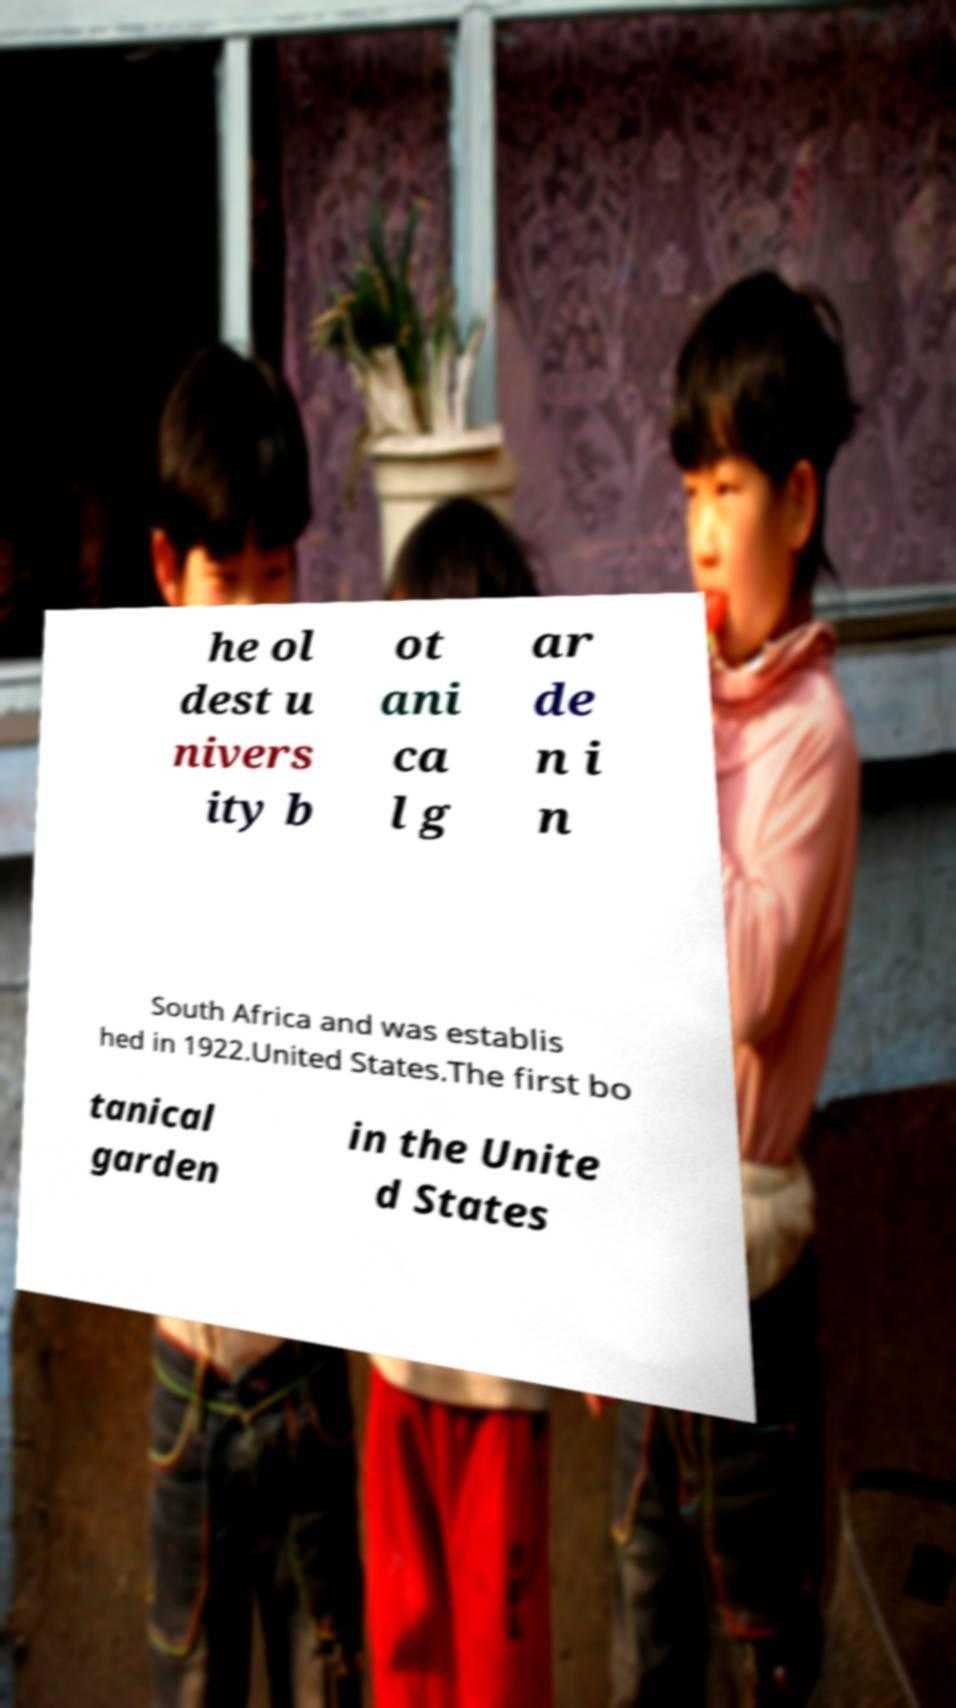Could you assist in decoding the text presented in this image and type it out clearly? he ol dest u nivers ity b ot ani ca l g ar de n i n South Africa and was establis hed in 1922.United States.The first bo tanical garden in the Unite d States 